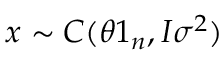<formula> <loc_0><loc_0><loc_500><loc_500>x \sim C ( \theta 1 _ { n } , I \sigma ^ { 2 } ) \,</formula> 